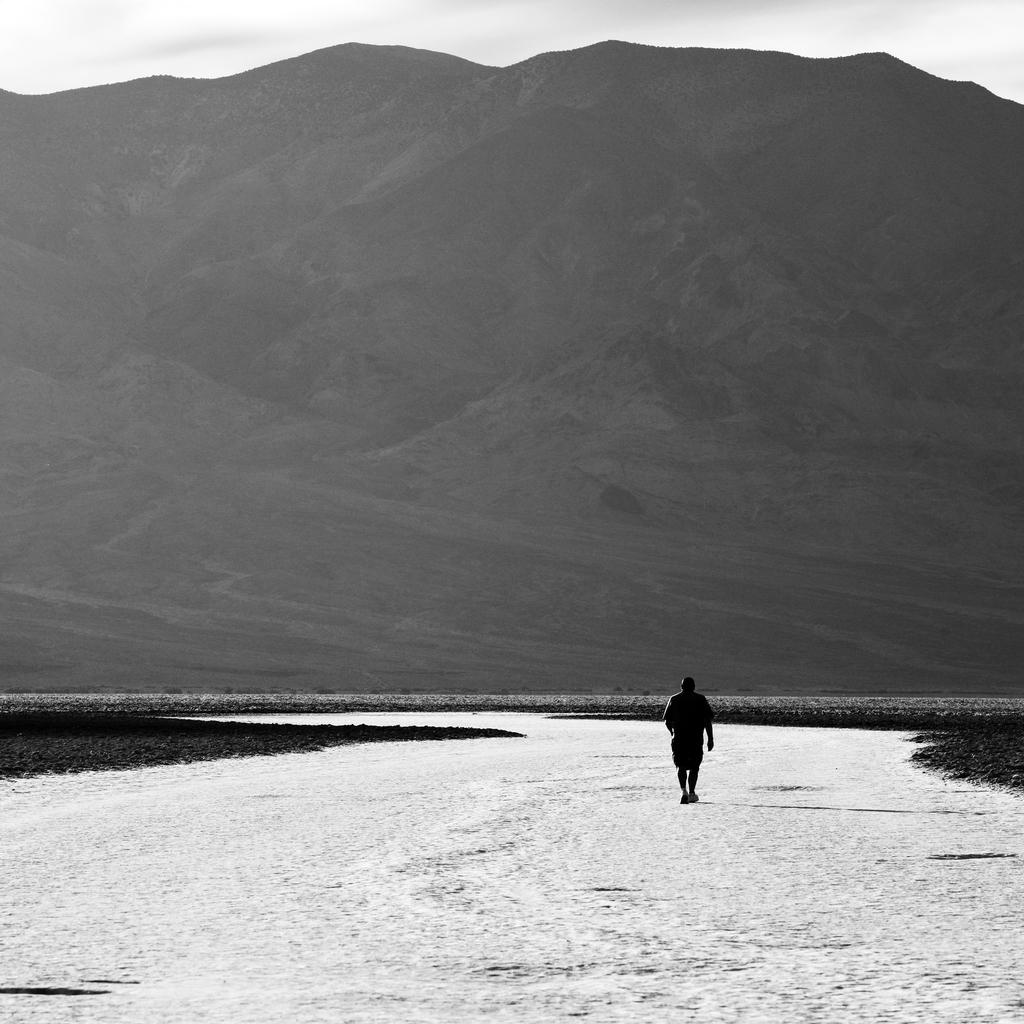What is the color scheme of the image? The image is black and white. Who or what can be seen in the image? There is a person in the image. Where is the person located in the image? The person is on a walkway. What can be seen in the background of the image? There is a hill and the sky visible in the background of the image. How many rings can be seen on the giraffe's neck in the image? There is no giraffe present in the image, and therefore no rings can be observed on its neck. 